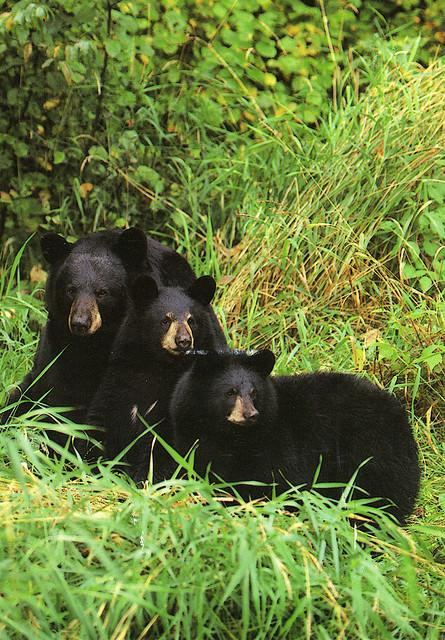What kind of diet do they adhere to? omnivore 